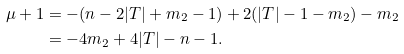<formula> <loc_0><loc_0><loc_500><loc_500>\mu + 1 & = - ( n - 2 | T | + m _ { 2 } - 1 ) + 2 ( | T | - 1 - m _ { 2 } ) - m _ { 2 } \\ & = - 4 m _ { 2 } + 4 | T | - n - 1 .</formula> 